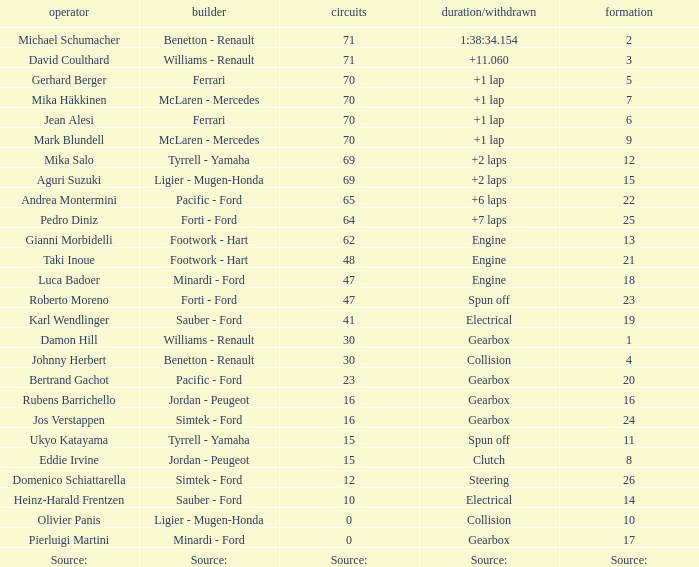Can you give me this table as a dict? {'header': ['operator', 'builder', 'circuits', 'duration/withdrawn', 'formation'], 'rows': [['Michael Schumacher', 'Benetton - Renault', '71', '1:38:34.154', '2'], ['David Coulthard', 'Williams - Renault', '71', '+11.060', '3'], ['Gerhard Berger', 'Ferrari', '70', '+1 lap', '5'], ['Mika Häkkinen', 'McLaren - Mercedes', '70', '+1 lap', '7'], ['Jean Alesi', 'Ferrari', '70', '+1 lap', '6'], ['Mark Blundell', 'McLaren - Mercedes', '70', '+1 lap', '9'], ['Mika Salo', 'Tyrrell - Yamaha', '69', '+2 laps', '12'], ['Aguri Suzuki', 'Ligier - Mugen-Honda', '69', '+2 laps', '15'], ['Andrea Montermini', 'Pacific - Ford', '65', '+6 laps', '22'], ['Pedro Diniz', 'Forti - Ford', '64', '+7 laps', '25'], ['Gianni Morbidelli', 'Footwork - Hart', '62', 'Engine', '13'], ['Taki Inoue', 'Footwork - Hart', '48', 'Engine', '21'], ['Luca Badoer', 'Minardi - Ford', '47', 'Engine', '18'], ['Roberto Moreno', 'Forti - Ford', '47', 'Spun off', '23'], ['Karl Wendlinger', 'Sauber - Ford', '41', 'Electrical', '19'], ['Damon Hill', 'Williams - Renault', '30', 'Gearbox', '1'], ['Johnny Herbert', 'Benetton - Renault', '30', 'Collision', '4'], ['Bertrand Gachot', 'Pacific - Ford', '23', 'Gearbox', '20'], ['Rubens Barrichello', 'Jordan - Peugeot', '16', 'Gearbox', '16'], ['Jos Verstappen', 'Simtek - Ford', '16', 'Gearbox', '24'], ['Ukyo Katayama', 'Tyrrell - Yamaha', '15', 'Spun off', '11'], ['Eddie Irvine', 'Jordan - Peugeot', '15', 'Clutch', '8'], ['Domenico Schiattarella', 'Simtek - Ford', '12', 'Steering', '26'], ['Heinz-Harald Frentzen', 'Sauber - Ford', '10', 'Electrical', '14'], ['Olivier Panis', 'Ligier - Mugen-Honda', '0', 'Collision', '10'], ['Pierluigi Martini', 'Minardi - Ford', '0', 'Gearbox', '17'], ['Source:', 'Source:', 'Source:', 'Source:', 'Source:']]} David Coulthard was the driver in which grid? 3.0. 